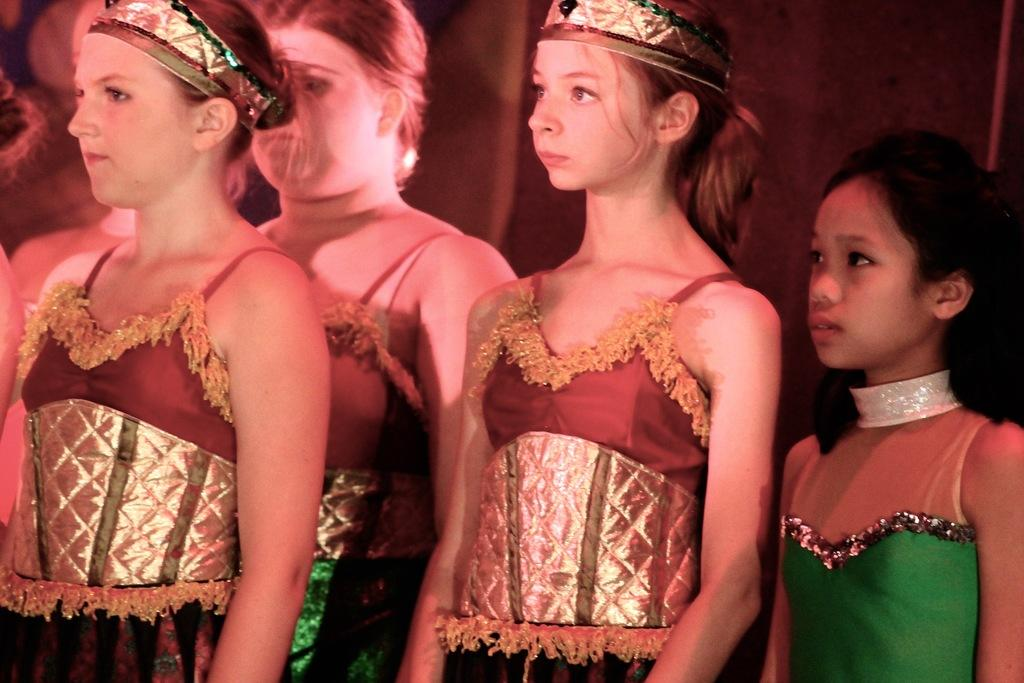What is the main subject of the image? The main subject of the image is the girls in the center. What are the girls doing in the image? The girls are standing in the image. What are the girls wearing in the image? The girls are dressed in costumes and wearing crowns. What type of marble is visible in the image? There is no marble present in the image. What kind of produce can be seen in the image? There is no produce present in the image. 